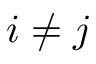<formula> <loc_0><loc_0><loc_500><loc_500>i \neq j</formula> 